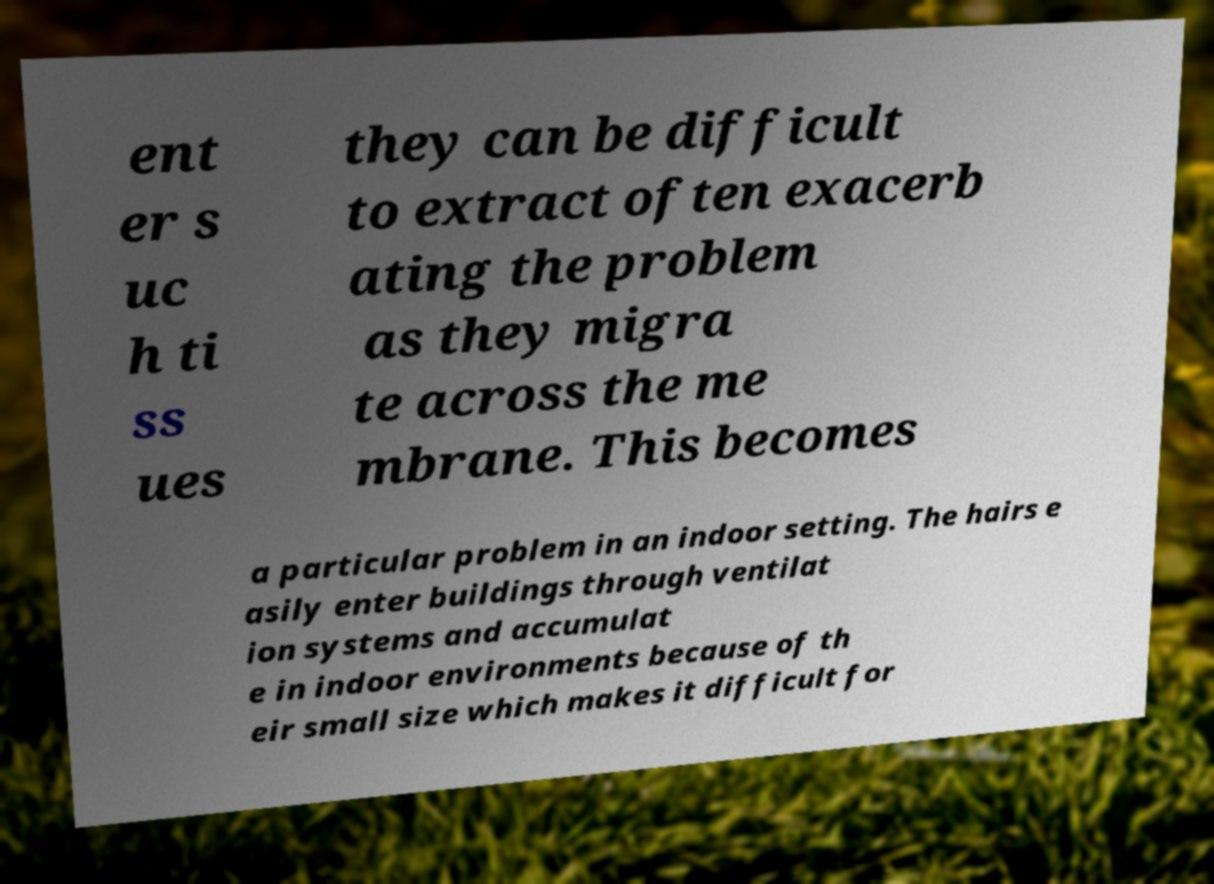What messages or text are displayed in this image? I need them in a readable, typed format. ent er s uc h ti ss ues they can be difficult to extract often exacerb ating the problem as they migra te across the me mbrane. This becomes a particular problem in an indoor setting. The hairs e asily enter buildings through ventilat ion systems and accumulat e in indoor environments because of th eir small size which makes it difficult for 